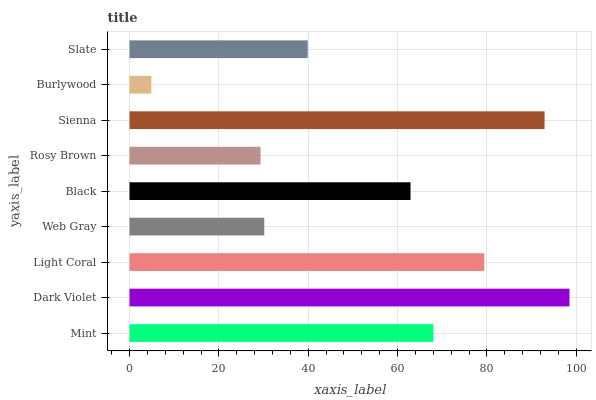Is Burlywood the minimum?
Answer yes or no. Yes. Is Dark Violet the maximum?
Answer yes or no. Yes. Is Light Coral the minimum?
Answer yes or no. No. Is Light Coral the maximum?
Answer yes or no. No. Is Dark Violet greater than Light Coral?
Answer yes or no. Yes. Is Light Coral less than Dark Violet?
Answer yes or no. Yes. Is Light Coral greater than Dark Violet?
Answer yes or no. No. Is Dark Violet less than Light Coral?
Answer yes or no. No. Is Black the high median?
Answer yes or no. Yes. Is Black the low median?
Answer yes or no. Yes. Is Light Coral the high median?
Answer yes or no. No. Is Burlywood the low median?
Answer yes or no. No. 